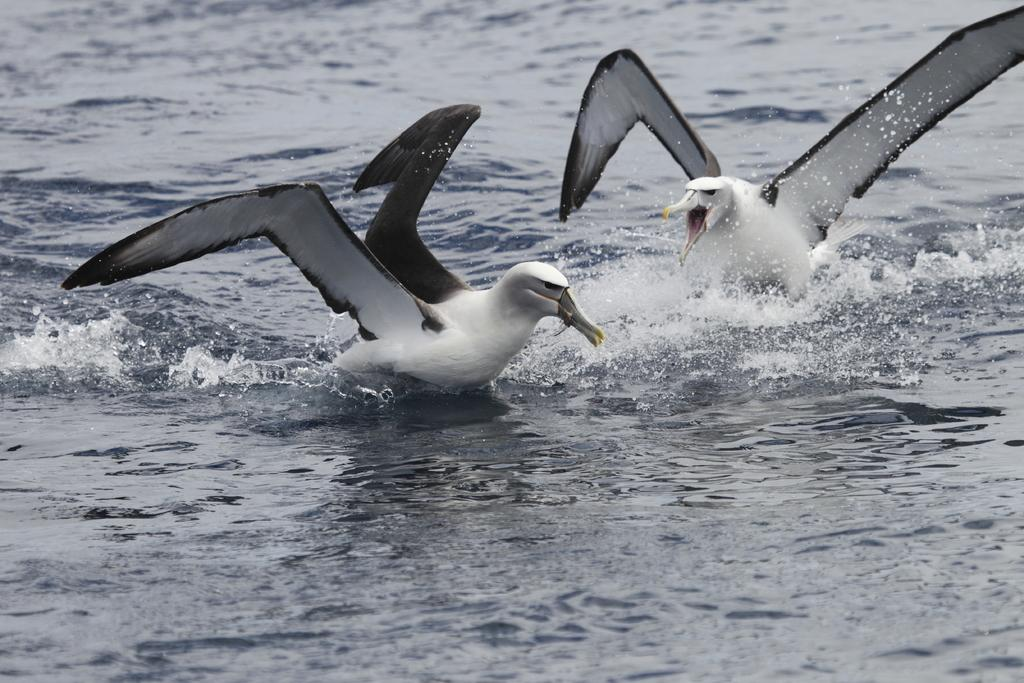What type of animals can be seen in the image? Birds can be seen in the image. Where are the birds situated in the image? The birds are in the water. What color is the canvas that the birds are standing on in the image? There is no canvas present in the image; the birds are in the water. What type of voice can be heard from the birds in the image? There is no sound or voice present in the image, as it is a still image. 